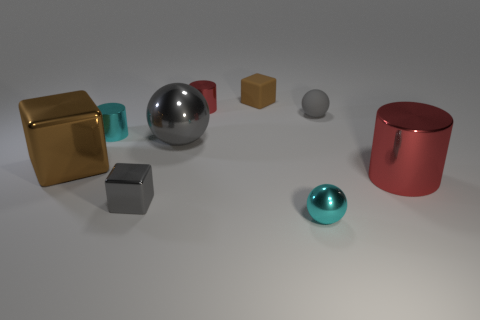Add 1 cyan metallic spheres. How many objects exist? 10 Subtract all cubes. How many objects are left? 6 Subtract all metal cubes. Subtract all small metal blocks. How many objects are left? 6 Add 7 small gray spheres. How many small gray spheres are left? 8 Add 7 small gray metallic blocks. How many small gray metallic blocks exist? 8 Subtract 0 yellow cylinders. How many objects are left? 9 